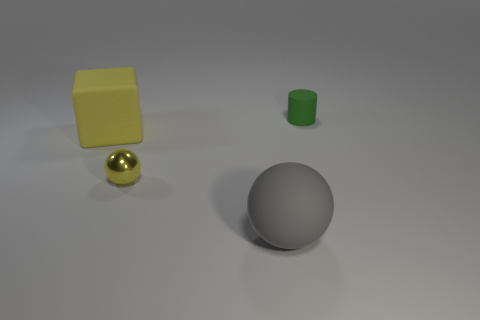Is there any other thing that has the same shape as the big yellow thing?
Offer a very short reply. No. Is there a matte thing of the same size as the gray sphere?
Make the answer very short. Yes. There is a thing behind the big yellow rubber cube; what is its material?
Give a very brief answer. Rubber. Do the big object in front of the cube and the tiny green cylinder have the same material?
Ensure brevity in your answer.  Yes. Is there a gray shiny thing?
Make the answer very short. No. There is a large cube that is the same material as the green cylinder; what color is it?
Give a very brief answer. Yellow. What color is the tiny object behind the yellow rubber object to the left of the small thing that is in front of the green matte object?
Offer a terse response. Green. There is a cylinder; is it the same size as the matte object that is on the left side of the gray ball?
Provide a succinct answer. No. What number of things are either green matte objects to the right of the large sphere or rubber objects in front of the green matte object?
Offer a terse response. 3. What is the shape of the green rubber thing that is the same size as the yellow shiny sphere?
Your response must be concise. Cylinder. 